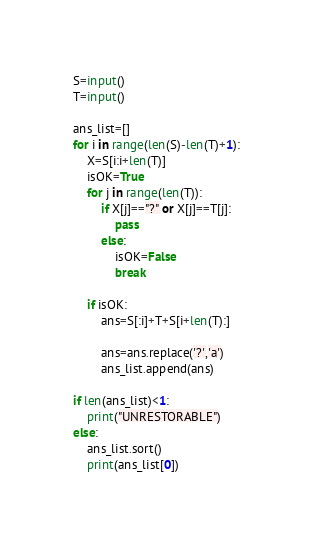Convert code to text. <code><loc_0><loc_0><loc_500><loc_500><_Python_>S=input()
T=input()

ans_list=[]
for i in range(len(S)-len(T)+1):
    X=S[i:i+len(T)]
    isOK=True
    for j in range(len(T)):
        if X[j]=="?" or X[j]==T[j]:
            pass
        else:
            isOK=False
            break
    
    if isOK:
        ans=S[:i]+T+S[i+len(T):]
        
        ans=ans.replace('?','a')
        ans_list.append(ans)

if len(ans_list)<1:
    print("UNRESTORABLE")
else:
    ans_list.sort()
    print(ans_list[0])
</code> 